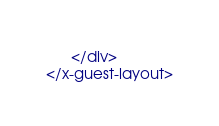Convert code to text. <code><loc_0><loc_0><loc_500><loc_500><_PHP_>      </div>
</x-guest-layout>
</code> 